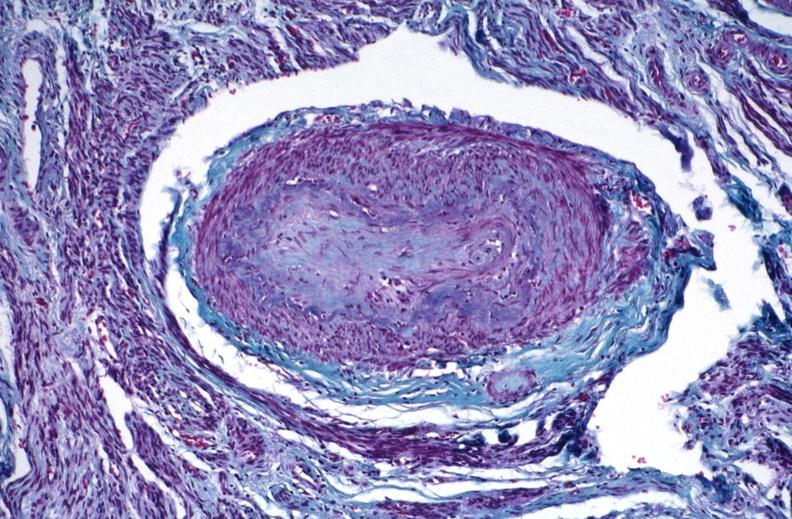do saggital section sternum with typical plasmacytoma stain?
Answer the question using a single word or phrase. No 